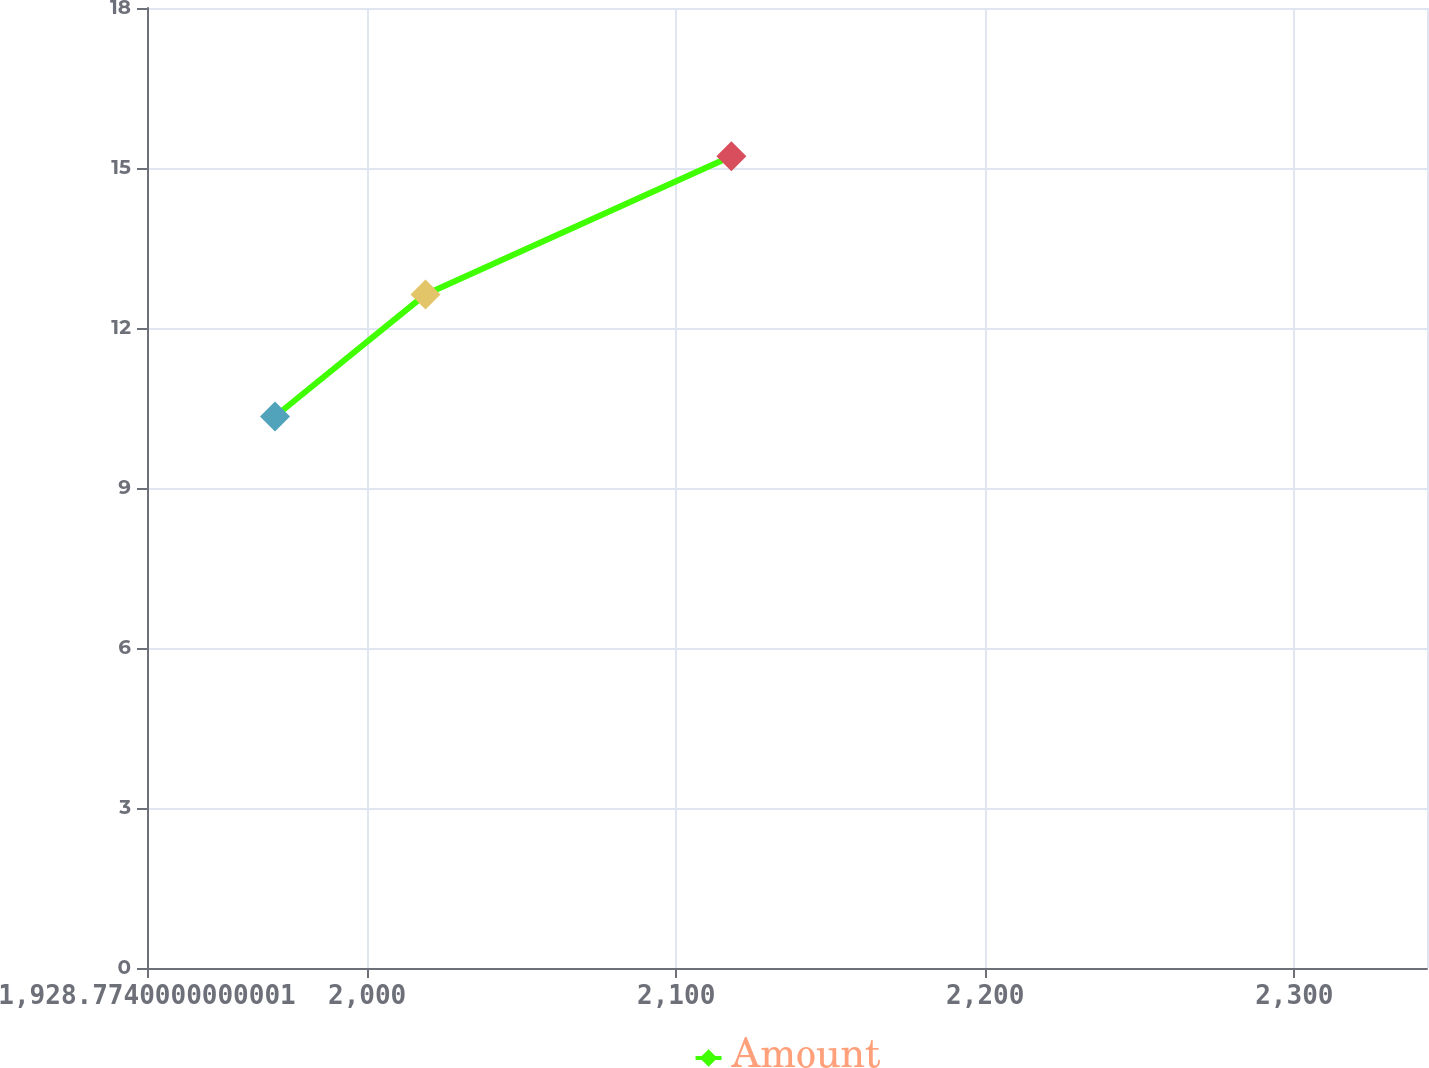Convert chart. <chart><loc_0><loc_0><loc_500><loc_500><line_chart><ecel><fcel>Amount<nl><fcel>1970.19<fcel>10.34<nl><fcel>2018.88<fcel>12.63<nl><fcel>2117.85<fcel>15.22<nl><fcel>2346.18<fcel>12.14<nl><fcel>2384.35<fcel>10.83<nl></chart> 